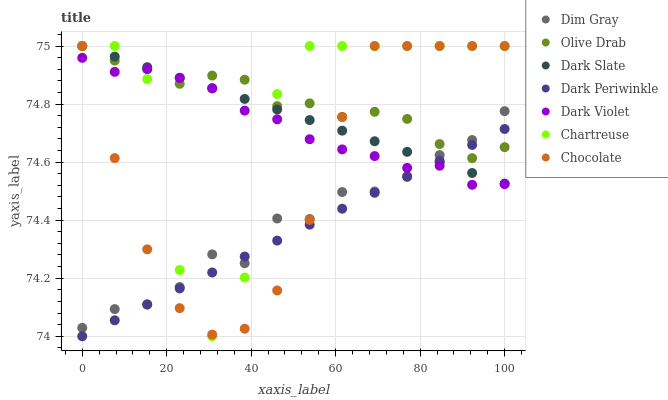Does Dark Periwinkle have the minimum area under the curve?
Answer yes or no. Yes. Does Olive Drab have the maximum area under the curve?
Answer yes or no. Yes. Does Dark Violet have the minimum area under the curve?
Answer yes or no. No. Does Dark Violet have the maximum area under the curve?
Answer yes or no. No. Is Dark Slate the smoothest?
Answer yes or no. Yes. Is Chartreuse the roughest?
Answer yes or no. Yes. Is Dark Violet the smoothest?
Answer yes or no. No. Is Dark Violet the roughest?
Answer yes or no. No. Does Dark Periwinkle have the lowest value?
Answer yes or no. Yes. Does Dark Violet have the lowest value?
Answer yes or no. No. Does Olive Drab have the highest value?
Answer yes or no. Yes. Does Dark Violet have the highest value?
Answer yes or no. No. Does Chocolate intersect Dark Violet?
Answer yes or no. Yes. Is Chocolate less than Dark Violet?
Answer yes or no. No. Is Chocolate greater than Dark Violet?
Answer yes or no. No. 